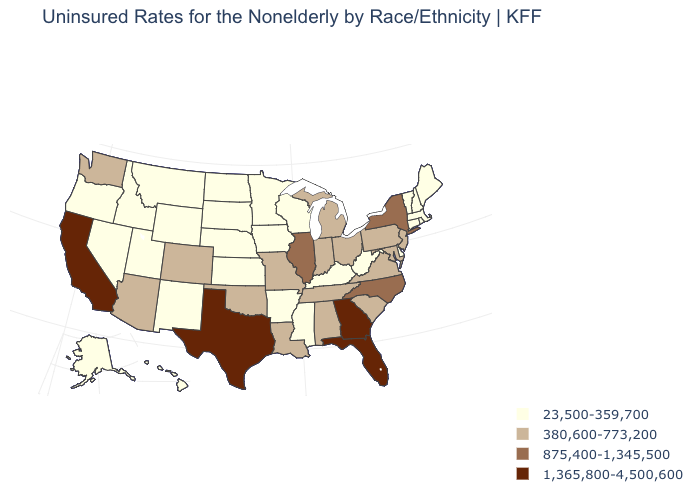What is the lowest value in the USA?
Concise answer only. 23,500-359,700. What is the value of New Hampshire?
Be succinct. 23,500-359,700. Does Georgia have the highest value in the USA?
Quick response, please. Yes. Among the states that border Tennessee , which have the lowest value?
Answer briefly. Arkansas, Kentucky, Mississippi. Does the first symbol in the legend represent the smallest category?
Answer briefly. Yes. What is the value of Texas?
Keep it brief. 1,365,800-4,500,600. Name the states that have a value in the range 380,600-773,200?
Be succinct. Alabama, Arizona, Colorado, Indiana, Louisiana, Maryland, Michigan, Missouri, New Jersey, Ohio, Oklahoma, Pennsylvania, South Carolina, Tennessee, Virginia, Washington. Does New York have the lowest value in the Northeast?
Short answer required. No. Among the states that border Texas , does New Mexico have the highest value?
Concise answer only. No. Does New Jersey have a lower value than Florida?
Short answer required. Yes. Among the states that border Michigan , does Wisconsin have the lowest value?
Be succinct. Yes. What is the lowest value in the USA?
Concise answer only. 23,500-359,700. What is the highest value in the South ?
Short answer required. 1,365,800-4,500,600. Name the states that have a value in the range 875,400-1,345,500?
Be succinct. Illinois, New York, North Carolina. Which states have the lowest value in the West?
Concise answer only. Alaska, Hawaii, Idaho, Montana, Nevada, New Mexico, Oregon, Utah, Wyoming. 